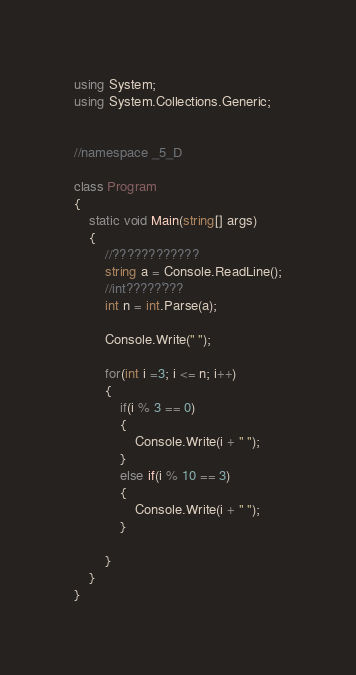Convert code to text. <code><loc_0><loc_0><loc_500><loc_500><_C#_>using System;
using System.Collections.Generic;


//namespace _5_D

class Program
{
    static void Main(string[] args)
    {
        //????????????
        string a = Console.ReadLine();
        //int?????´???
        int n = int.Parse(a);

        Console.Write(" ");

        for(int i =3; i <= n; i++)
        {
            if(i % 3 == 0)
            {
                Console.Write(i + " ");
            }
            else if(i % 10 == 3)
            {
                Console.Write(i + " ");
            }
            
        }
    }
}</code> 